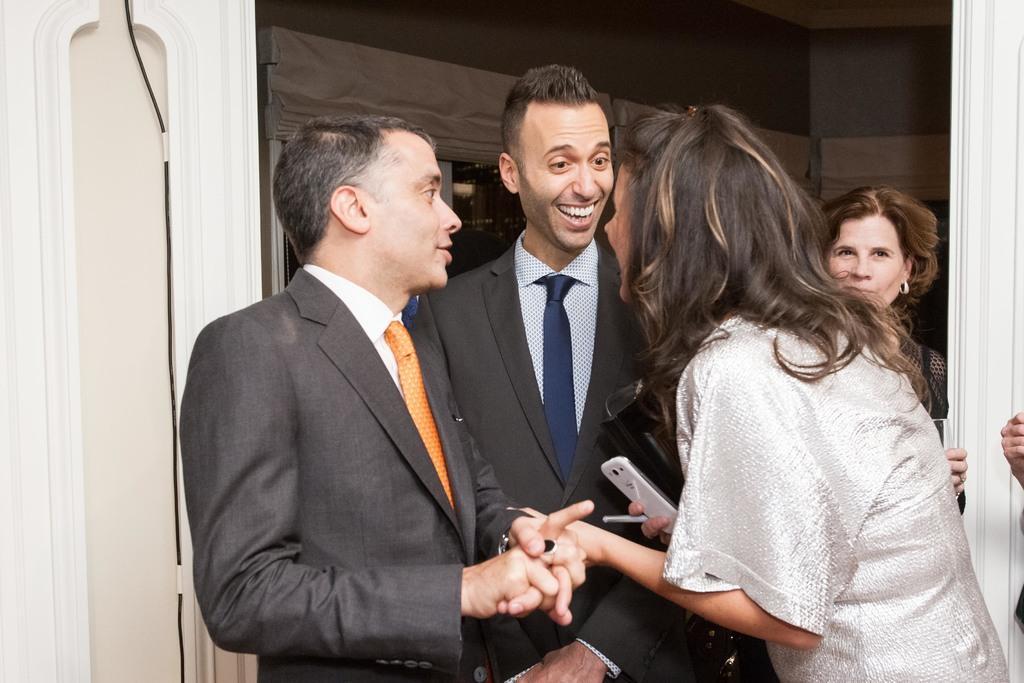Can you describe this image briefly? In this image there are people, walls, curtains and window. People are holding objects.   